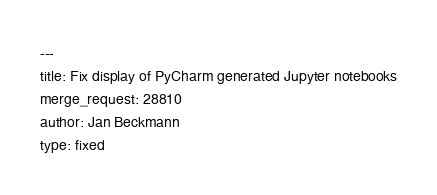Convert code to text. <code><loc_0><loc_0><loc_500><loc_500><_YAML_>---
title: Fix display of PyCharm generated Jupyter notebooks
merge_request: 28810
author: Jan Beckmann
type: fixed
</code> 